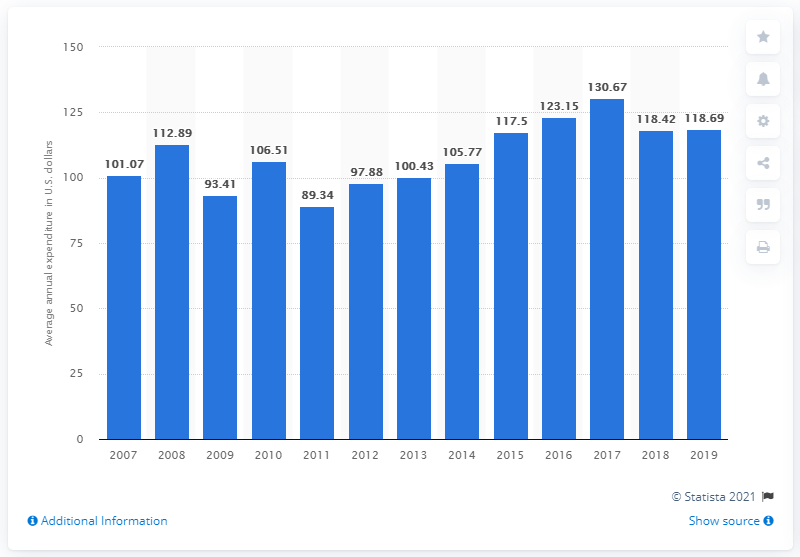Draw attention to some important aspects in this diagram. In 2019, the average expenditure on small appliances and miscellaneous housewares per consumer unit in the United States was 118.69 dollars. 